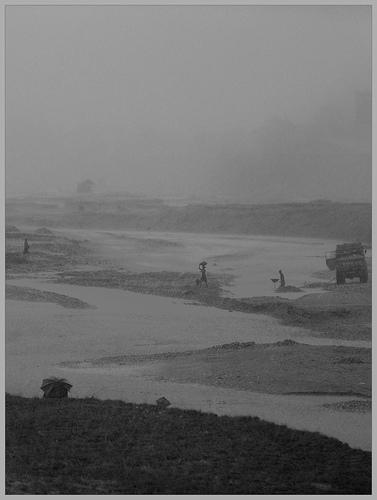Is this safe weather for aircraft?
Write a very short answer. No. What color should the sky be if the picture was in color?
Be succinct. Gray. Is it snow storming in this picture?
Concise answer only. Yes. Is the picture colorful?
Concise answer only. No. Where is the sun in this image?
Write a very short answer. No. Can you see water?
Concise answer only. Yes. Is the ground covered in sand?
Write a very short answer. Yes. How many benches are photographed?
Concise answer only. 0. 